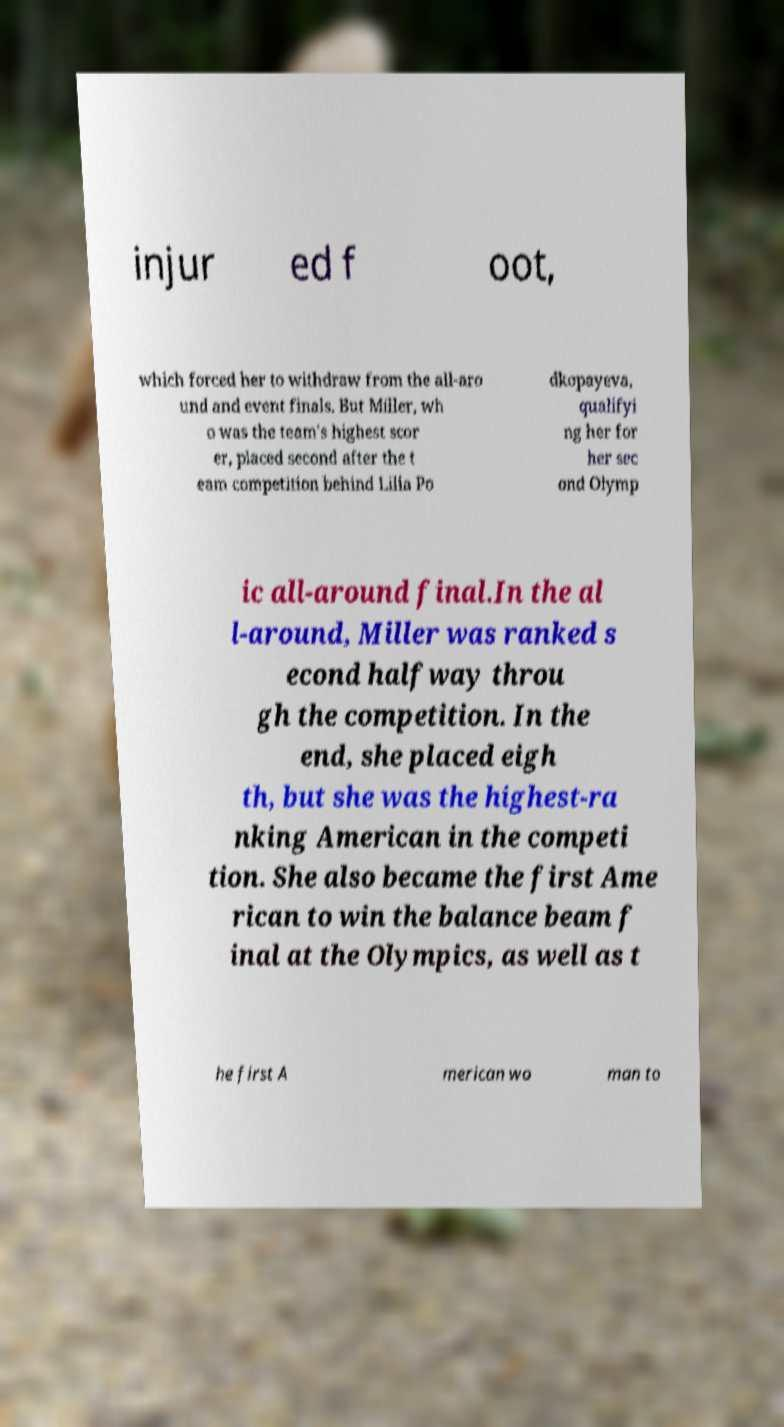Can you accurately transcribe the text from the provided image for me? injur ed f oot, which forced her to withdraw from the all-aro und and event finals. But Miller, wh o was the team's highest scor er, placed second after the t eam competition behind Lilia Po dkopayeva, qualifyi ng her for her sec ond Olymp ic all-around final.In the al l-around, Miller was ranked s econd halfway throu gh the competition. In the end, she placed eigh th, but she was the highest-ra nking American in the competi tion. She also became the first Ame rican to win the balance beam f inal at the Olympics, as well as t he first A merican wo man to 